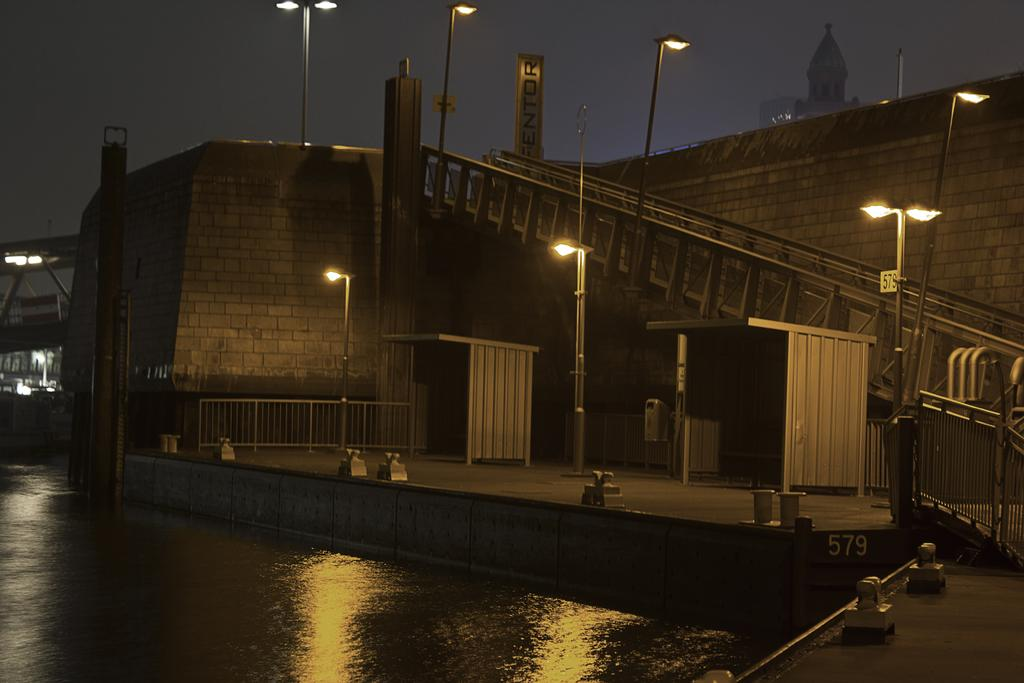What type of structures can be seen in the image? There are buildings in the image. Can you describe a specific architectural feature in the image? There is a staircase in the image. What safety feature is present in the image? Railings are present in the image. What type of cooking appliance is visible in the image? Grills are visible in the image. What type of urban infrastructure can be seen in the image? Street poles and street lights are in the image. What type of barrier is present in the image? Barriers are present in the image. What type of natural feature is visible in the image? There is a lake in the image. What part of the natural environment is visible in the image? The sky is visible in the image. What type of hot spark can be seen flying through the air in the image? There is no hot spark present in the image. What type of route is visible in the image? There is no route visible in the image; it is a static scene with buildings, a staircase, railings, grills, street poles, street lights, barriers, a lake, and the sky. 